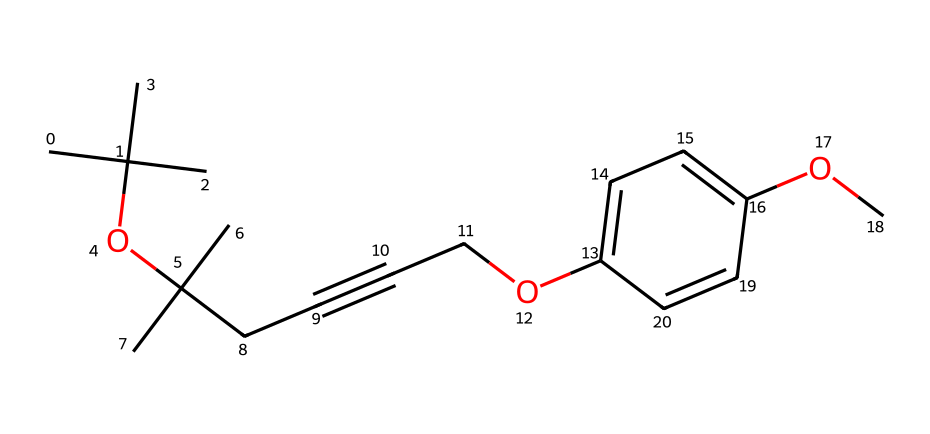how many carbon atoms are in this ether? By examining the SMILES representation closely, we can identify the number of 'C' symbols in the structure. In this case, there are 15 carbon atoms present.
Answer: 15 what is the main functional group in this chemical? The main functional group in this structure is the ether group, which is characterized by the 'O' atom connecting two hydrocarbon chains. This can be observed from the 'OC' present in the SMILES.
Answer: ether how many oxygen atoms are in this chemical? Counting the 'O' symbols in the SMILES notation, we find that there are 2 oxygen atoms present in this structure.
Answer: 2 how many double bonds are in the molecule? By looking at the SMILES structure, we identify the presence of double bonds. The '#C' indicates a triple bond, while 'C=C' indicates a double bond. In total, there is one double bond indicated in this molecule.
Answer: 1 is this compound likely to be polar or nonpolar? Given that ethers generally have nonpolar hydrocarbon groups surrounding the polar ether oxygen atom, this compound is likely to be nonpolar overall due to the significant presence of carbon groups.
Answer: nonpolar what type of hydrocarbon chains are present in this ether? The hydrocarbon chains observed in this ether are branched alkyl chains, as indicated by the multiple 'C' symbols and their connections showing branching.
Answer: branched alkyl does this ether have any aromatic rings? Yes, the presence of 'C1=CC=C(OC)C=C1' in the SMILES indicates the existence of an aromatic ring structure within this ether.
Answer: yes 